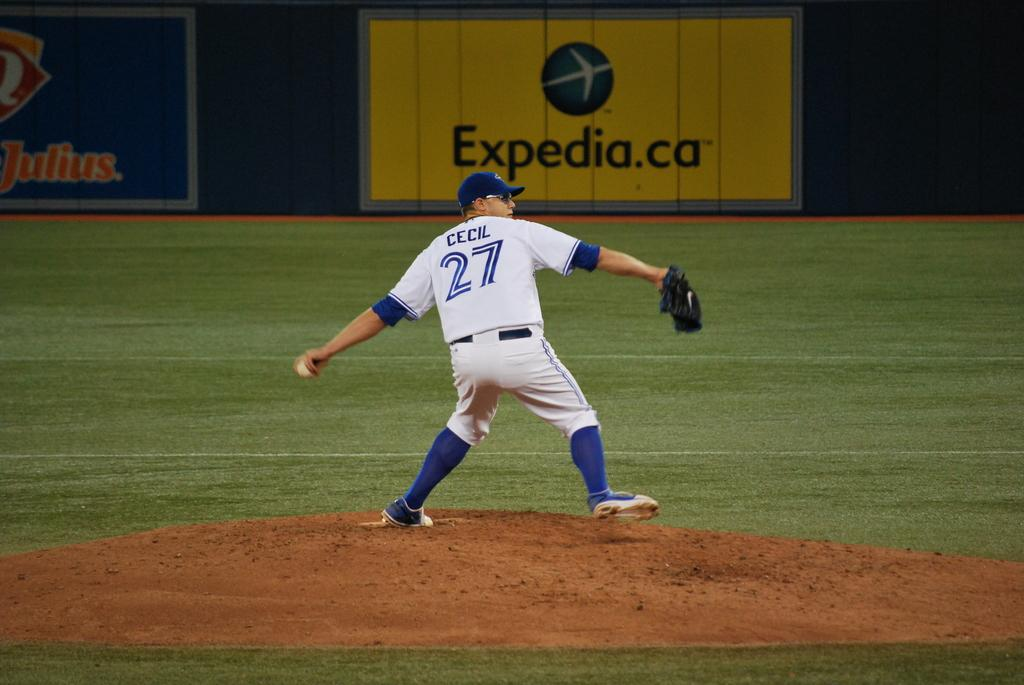<image>
Describe the image concisely. A baseball player with cecil on the back of his shirt in front of a sign that says Expedia.ca. 